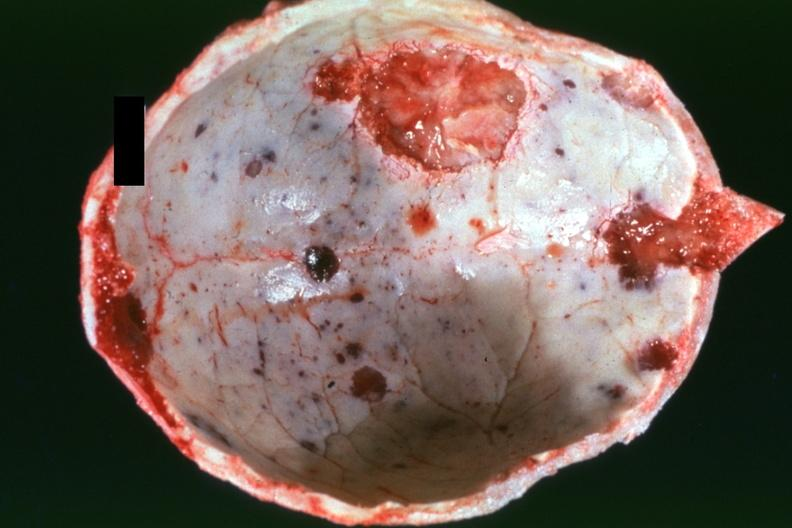what is present?
Answer the question using a single word or phrase. Multiple myeloma 